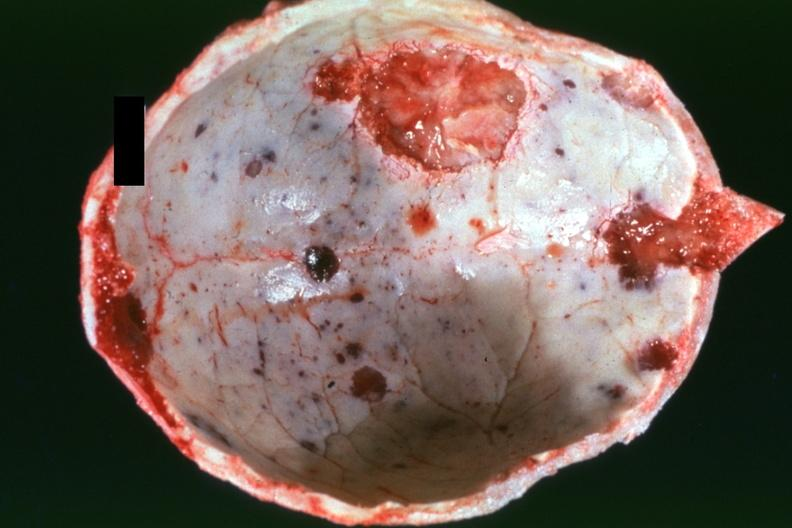what is present?
Answer the question using a single word or phrase. Multiple myeloma 